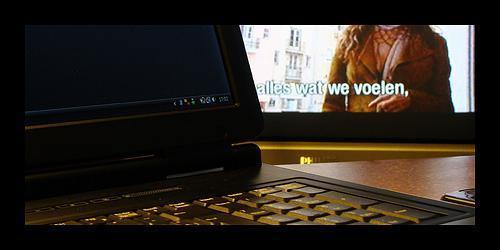How many people on the table?
Give a very brief answer. 0. 